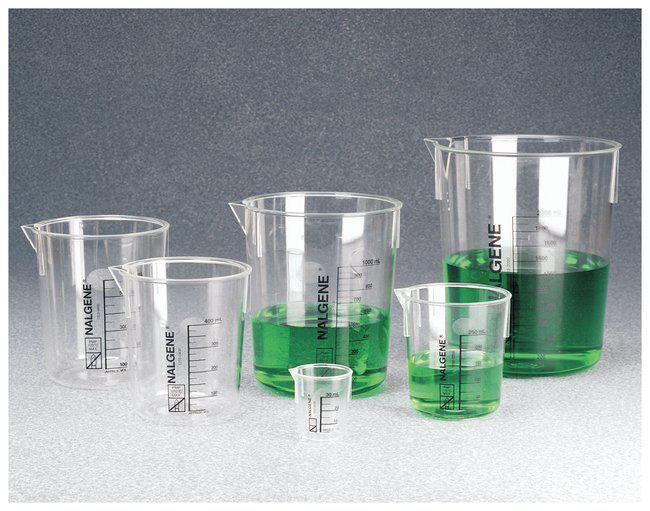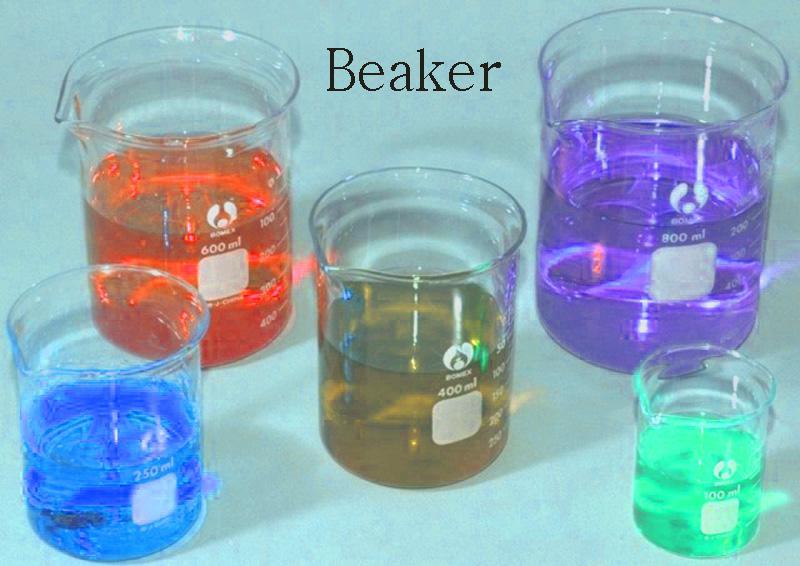The first image is the image on the left, the second image is the image on the right. For the images displayed, is the sentence "There are unfilled beakers." factually correct? Answer yes or no. Yes. 